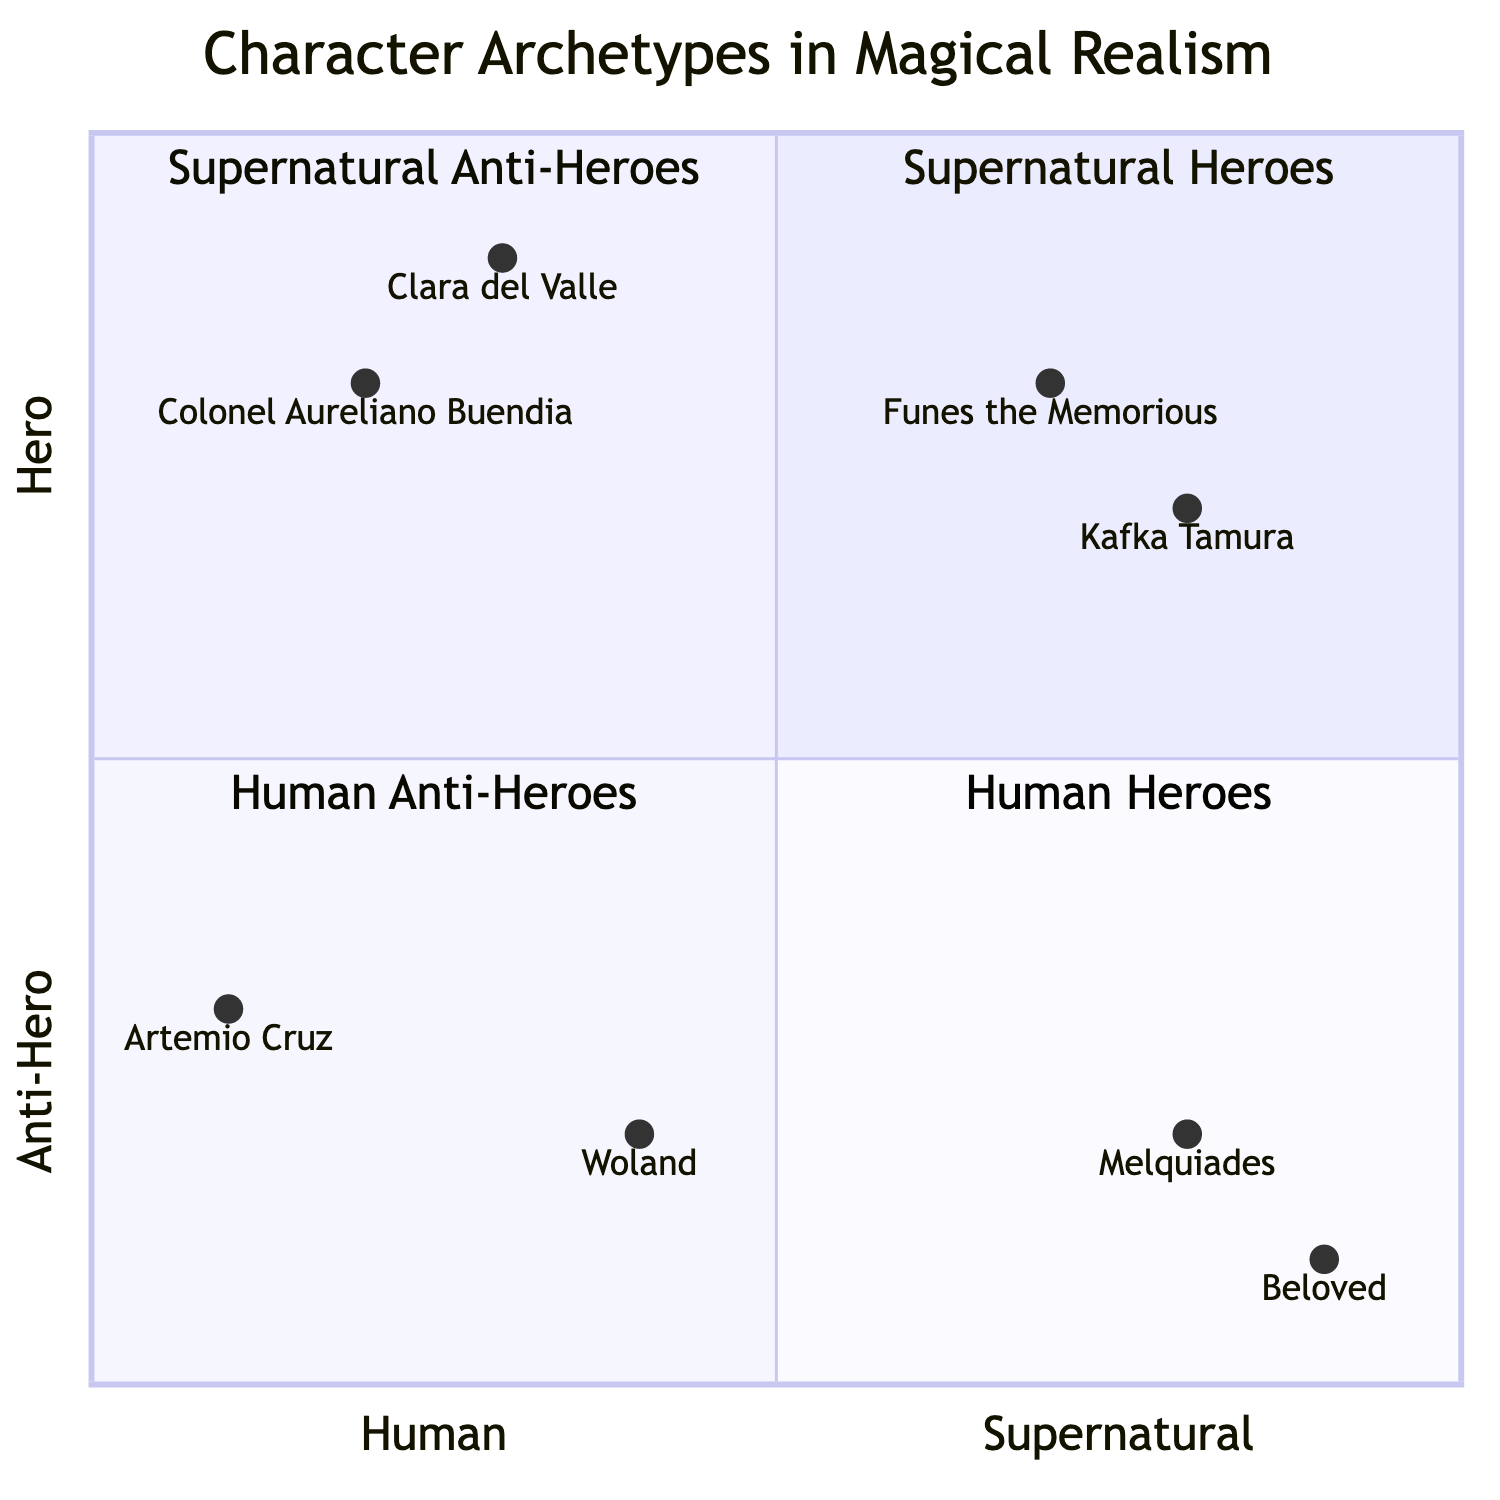What characters represent Human Heroes? In the quadrant for Human Heroes (quadrant 4), the characters listed are Colonel Aureliano Buendia and Clara del Valle.
Answer: Colonel Aureliano Buendia, Clara del Valle Which character occupies the position for Supernatural Anti-Hero? The character located in the Supernatural Anti-Hero quadrant (quadrant 2) is Beloved.
Answer: Beloved How many characters are categorized as Anti-Heroes? There are four characters placed in the Anti-Hero categories, two human and two supernatural: Woland, Artemio Cruz, Beloved, and Melquiades.
Answer: 4 Which character has the highest placement on the y-axis? The character with the highest placement on the y-axis (indicating Hero status) is Clara del Valle, positioned at 0.9.
Answer: Clara del Valle What is the trait of Funes the Memorious? Funes the Memorious is described as "A man with perfect memory, representing the burden of unbounded knowledge."
Answer: A man with perfect memory Which quadrant contains more Human characters: Human Heroes or Human Anti-Heroes? The Human Heroes quadrant has two characters (Colonel Aureliano Buendia, Clara del Valle) while the Human Anti-Heroes also has two characters (Woland, Artemio Cruz), so they are equal in number.
Answer: Equal Who is the character that explores hypocrisy and corruption? The character exploring hypocrisy and corruption in Soviet society is Woland.
Answer: Woland Which character has a placement closest to the Supernatural side of the chart? The character closest to the Supernatural side of the chart is Beloved, with a coordinate of [0.9, 0.1].
Answer: Beloved 